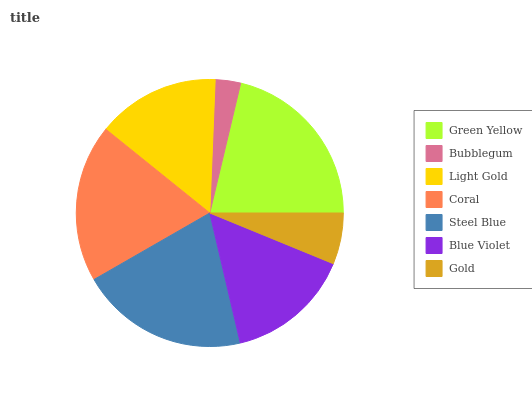Is Bubblegum the minimum?
Answer yes or no. Yes. Is Green Yellow the maximum?
Answer yes or no. Yes. Is Light Gold the minimum?
Answer yes or no. No. Is Light Gold the maximum?
Answer yes or no. No. Is Light Gold greater than Bubblegum?
Answer yes or no. Yes. Is Bubblegum less than Light Gold?
Answer yes or no. Yes. Is Bubblegum greater than Light Gold?
Answer yes or no. No. Is Light Gold less than Bubblegum?
Answer yes or no. No. Is Blue Violet the high median?
Answer yes or no. Yes. Is Blue Violet the low median?
Answer yes or no. Yes. Is Green Yellow the high median?
Answer yes or no. No. Is Coral the low median?
Answer yes or no. No. 